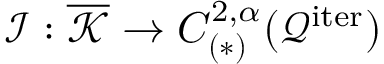Convert formula to latex. <formula><loc_0><loc_0><loc_500><loc_500>\mathcal { I } \colon \overline { { \mathcal { K } } } \rightarrow C _ { ( * ) } ^ { 2 , \alpha } ( \mathcal { Q } ^ { i t e r } )</formula> 